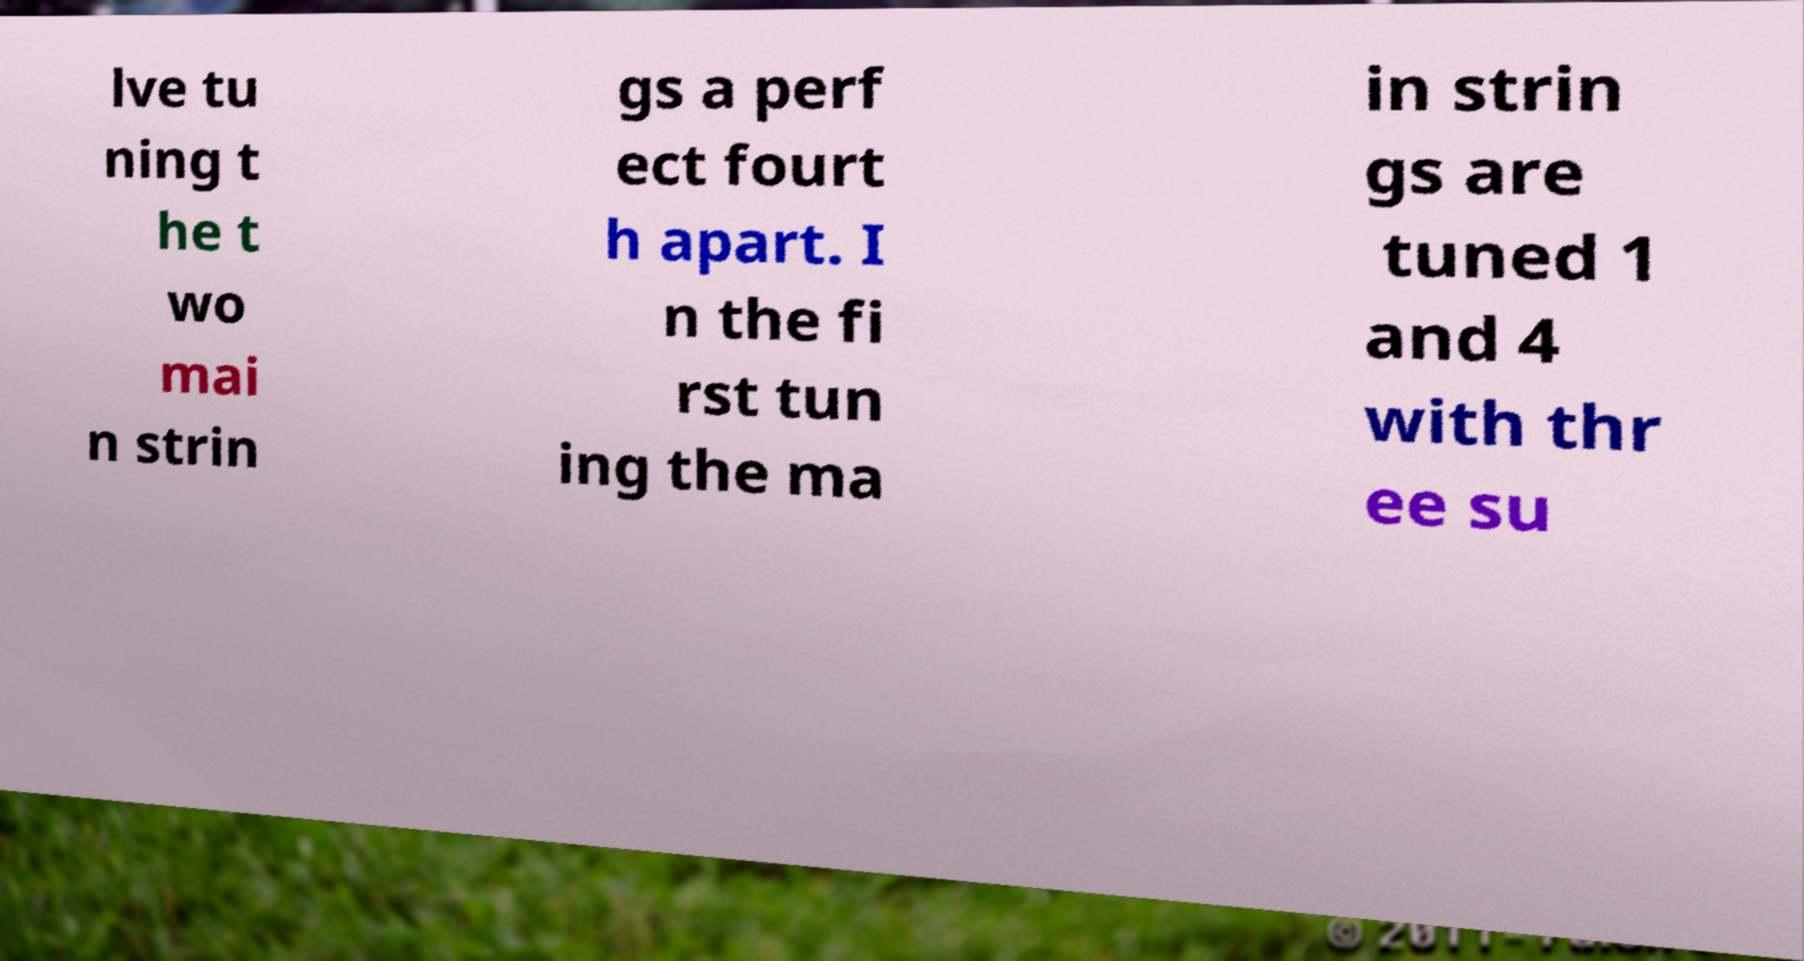There's text embedded in this image that I need extracted. Can you transcribe it verbatim? lve tu ning t he t wo mai n strin gs a perf ect fourt h apart. I n the fi rst tun ing the ma in strin gs are tuned 1 and 4 with thr ee su 